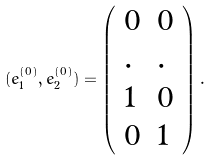<formula> <loc_0><loc_0><loc_500><loc_500>( { e } _ { 1 } ^ { ( 0 ) } , { e } _ { 2 } ^ { ( 0 ) } ) = \left ( \begin{array} { l l } 0 & 0 \\ . & . \\ 1 & 0 \\ 0 & 1 \end{array} \right ) .</formula> 